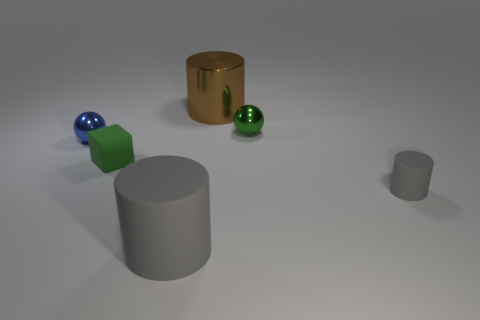Does the metallic cylinder have the same size as the green metal thing?
Offer a terse response. No. What number of other things are the same shape as the tiny gray thing?
Your response must be concise. 2. What shape is the small green thing that is to the left of the brown cylinder?
Your response must be concise. Cube. Does the green thing behind the small blue sphere have the same shape as the tiny gray object in front of the small cube?
Keep it short and to the point. No. Are there the same number of tiny green metallic things to the right of the big brown metal cylinder and cyan cubes?
Your answer should be compact. No. Are there any other things that have the same size as the green metallic sphere?
Give a very brief answer. Yes. There is another object that is the same shape as the green metal thing; what is it made of?
Give a very brief answer. Metal. There is a matte object that is on the left side of the gray rubber object that is to the left of the shiny cylinder; what shape is it?
Your answer should be very brief. Cube. Is the material of the large cylinder that is behind the blue sphere the same as the tiny gray thing?
Keep it short and to the point. No. Is the number of brown metallic things that are left of the small blue object the same as the number of small balls that are to the right of the small gray matte object?
Offer a terse response. Yes. 